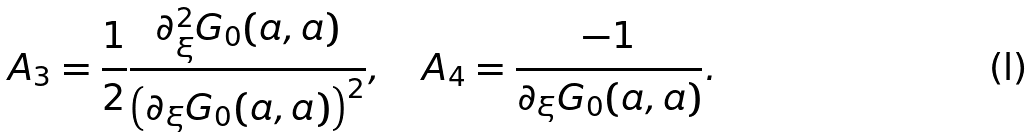<formula> <loc_0><loc_0><loc_500><loc_500>A _ { 3 } = \frac { 1 } { 2 } \frac { \partial _ { \xi } ^ { 2 } G _ { 0 } ( a , a ) } { \left ( \partial _ { \xi } G _ { 0 } ( a , a ) \right ) ^ { 2 } } , \quad A _ { 4 } = \frac { - 1 } { \partial _ { \xi } G _ { 0 } ( a , a ) } .</formula> 